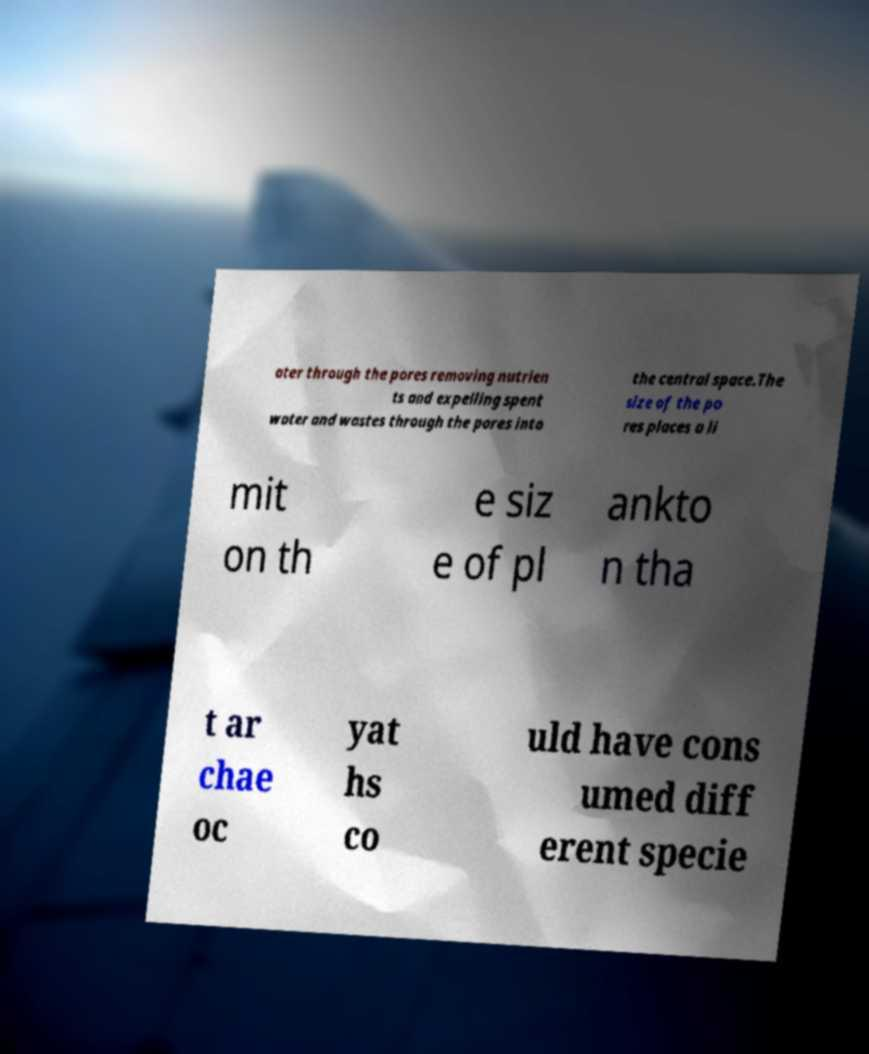I need the written content from this picture converted into text. Can you do that? ater through the pores removing nutrien ts and expelling spent water and wastes through the pores into the central space.The size of the po res places a li mit on th e siz e of pl ankto n tha t ar chae oc yat hs co uld have cons umed diff erent specie 